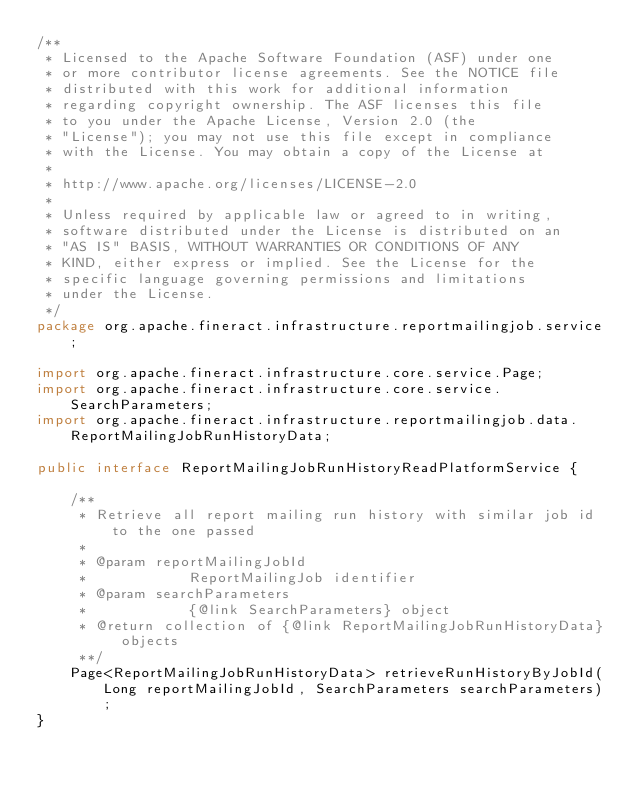<code> <loc_0><loc_0><loc_500><loc_500><_Java_>/**
 * Licensed to the Apache Software Foundation (ASF) under one
 * or more contributor license agreements. See the NOTICE file
 * distributed with this work for additional information
 * regarding copyright ownership. The ASF licenses this file
 * to you under the Apache License, Version 2.0 (the
 * "License"); you may not use this file except in compliance
 * with the License. You may obtain a copy of the License at
 *
 * http://www.apache.org/licenses/LICENSE-2.0
 *
 * Unless required by applicable law or agreed to in writing,
 * software distributed under the License is distributed on an
 * "AS IS" BASIS, WITHOUT WARRANTIES OR CONDITIONS OF ANY
 * KIND, either express or implied. See the License for the
 * specific language governing permissions and limitations
 * under the License.
 */
package org.apache.fineract.infrastructure.reportmailingjob.service;

import org.apache.fineract.infrastructure.core.service.Page;
import org.apache.fineract.infrastructure.core.service.SearchParameters;
import org.apache.fineract.infrastructure.reportmailingjob.data.ReportMailingJobRunHistoryData;

public interface ReportMailingJobRunHistoryReadPlatformService {

    /**
     * Retrieve all report mailing run history with similar job id to the one passed
     *
     * @param reportMailingJobId
     *            ReportMailingJob identifier
     * @param searchParameters
     *            {@link SearchParameters} object
     * @return collection of {@link ReportMailingJobRunHistoryData} objects
     **/
    Page<ReportMailingJobRunHistoryData> retrieveRunHistoryByJobId(Long reportMailingJobId, SearchParameters searchParameters);
}
</code> 